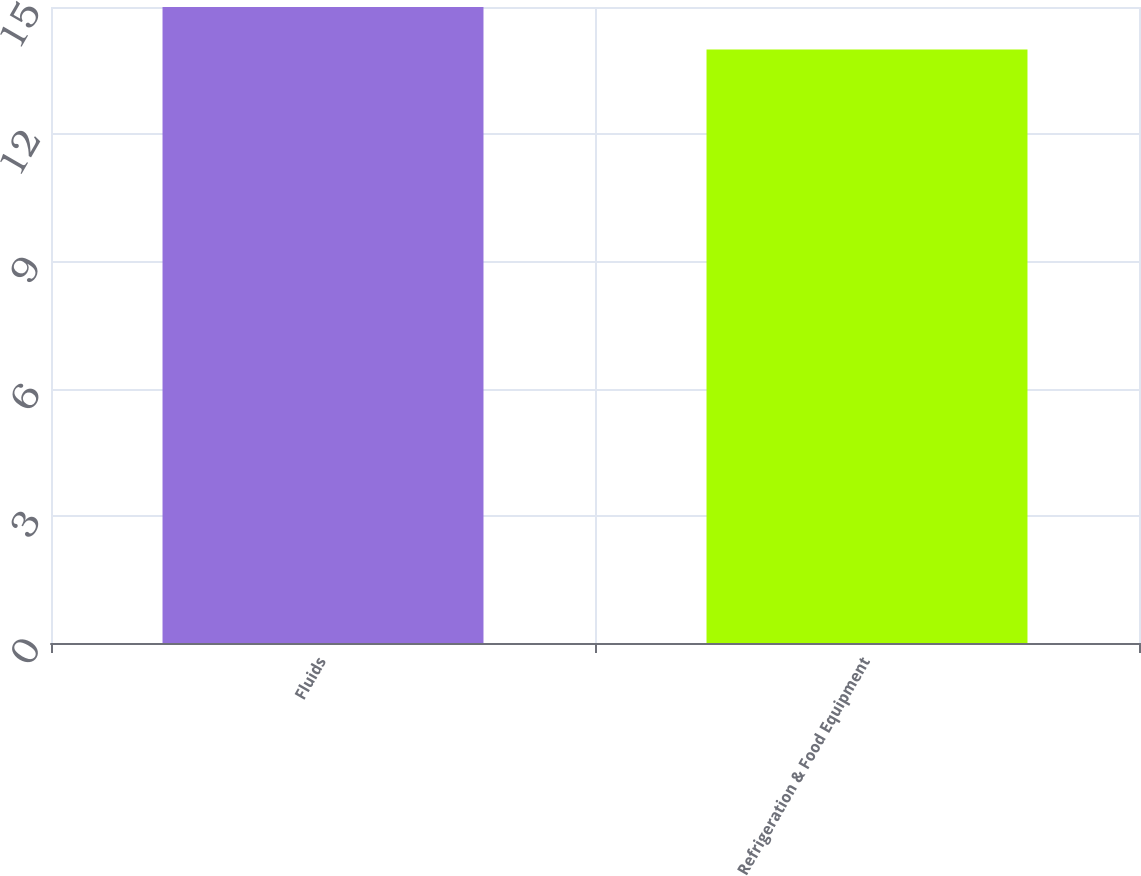Convert chart to OTSL. <chart><loc_0><loc_0><loc_500><loc_500><bar_chart><fcel>Fluids<fcel>Refrigeration & Food Equipment<nl><fcel>15<fcel>14<nl></chart> 